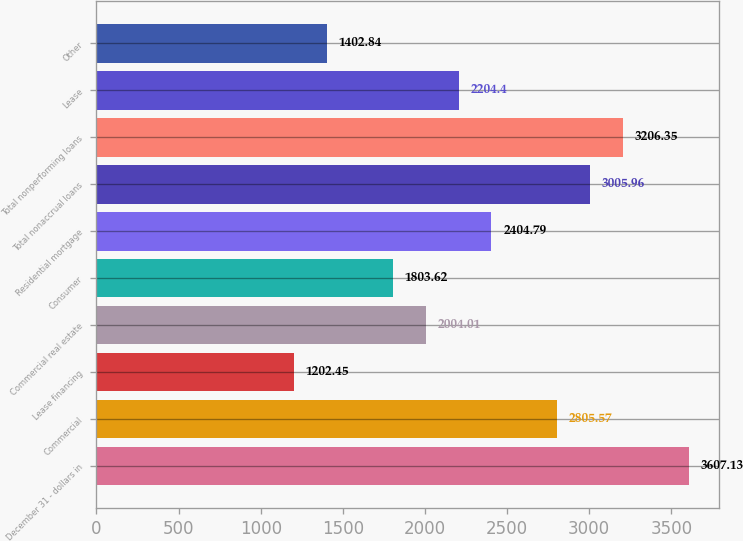<chart> <loc_0><loc_0><loc_500><loc_500><bar_chart><fcel>December 31 - dollars in<fcel>Commercial<fcel>Lease financing<fcel>Commercial real estate<fcel>Consumer<fcel>Residential mortgage<fcel>Total nonaccrual loans<fcel>Total nonperforming loans<fcel>Lease<fcel>Other<nl><fcel>3607.13<fcel>2805.57<fcel>1202.45<fcel>2004.01<fcel>1803.62<fcel>2404.79<fcel>3005.96<fcel>3206.35<fcel>2204.4<fcel>1402.84<nl></chart> 